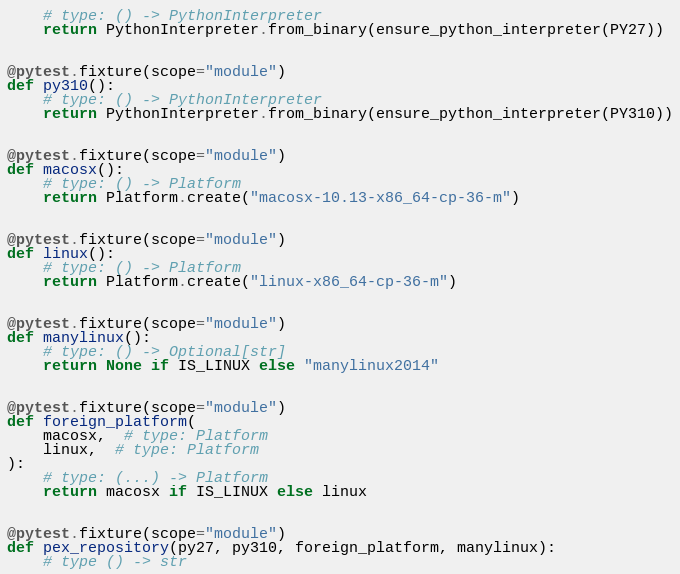<code> <loc_0><loc_0><loc_500><loc_500><_Python_>    # type: () -> PythonInterpreter
    return PythonInterpreter.from_binary(ensure_python_interpreter(PY27))


@pytest.fixture(scope="module")
def py310():
    # type: () -> PythonInterpreter
    return PythonInterpreter.from_binary(ensure_python_interpreter(PY310))


@pytest.fixture(scope="module")
def macosx():
    # type: () -> Platform
    return Platform.create("macosx-10.13-x86_64-cp-36-m")


@pytest.fixture(scope="module")
def linux():
    # type: () -> Platform
    return Platform.create("linux-x86_64-cp-36-m")


@pytest.fixture(scope="module")
def manylinux():
    # type: () -> Optional[str]
    return None if IS_LINUX else "manylinux2014"


@pytest.fixture(scope="module")
def foreign_platform(
    macosx,  # type: Platform
    linux,  # type: Platform
):
    # type: (...) -> Platform
    return macosx if IS_LINUX else linux


@pytest.fixture(scope="module")
def pex_repository(py27, py310, foreign_platform, manylinux):
    # type () -> str
</code> 